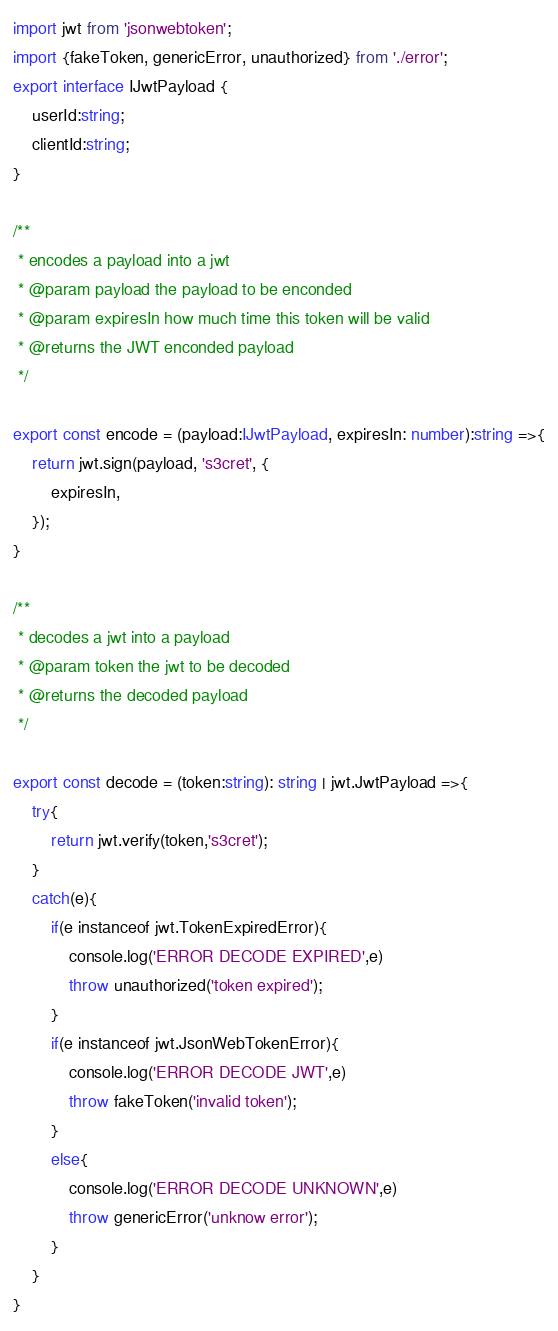Convert code to text. <code><loc_0><loc_0><loc_500><loc_500><_TypeScript_>import jwt from 'jsonwebtoken';
import {fakeToken, genericError, unauthorized} from './error';
export interface IJwtPayload {
    userId:string;
    clientId:string;
}

/**
 * encodes a payload into a jwt
 * @param payload the payload to be enconded
 * @param expiresIn how much time this token will be valid 
 * @returns the JWT enconded payload
 */

export const encode = (payload:IJwtPayload, expiresIn: number):string =>{
    return jwt.sign(payload, 's3cret', {
        expiresIn,
    });
}

/**
 * decodes a jwt into a payload
 * @param token the jwt to be decoded 
 * @returns the decoded payload
 */

export const decode = (token:string): string | jwt.JwtPayload =>{
    try{
        return jwt.verify(token,'s3cret');
    }
    catch(e){
        if(e instanceof jwt.TokenExpiredError){
            console.log('ERROR DECODE EXPIRED',e)
            throw unauthorized('token expired');
        }
        if(e instanceof jwt.JsonWebTokenError){
            console.log('ERROR DECODE JWT',e)
            throw fakeToken('invalid token');
        }
        else{
            console.log('ERROR DECODE UNKNOWN',e)
            throw genericError('unknow error');
        }
    }
}</code> 